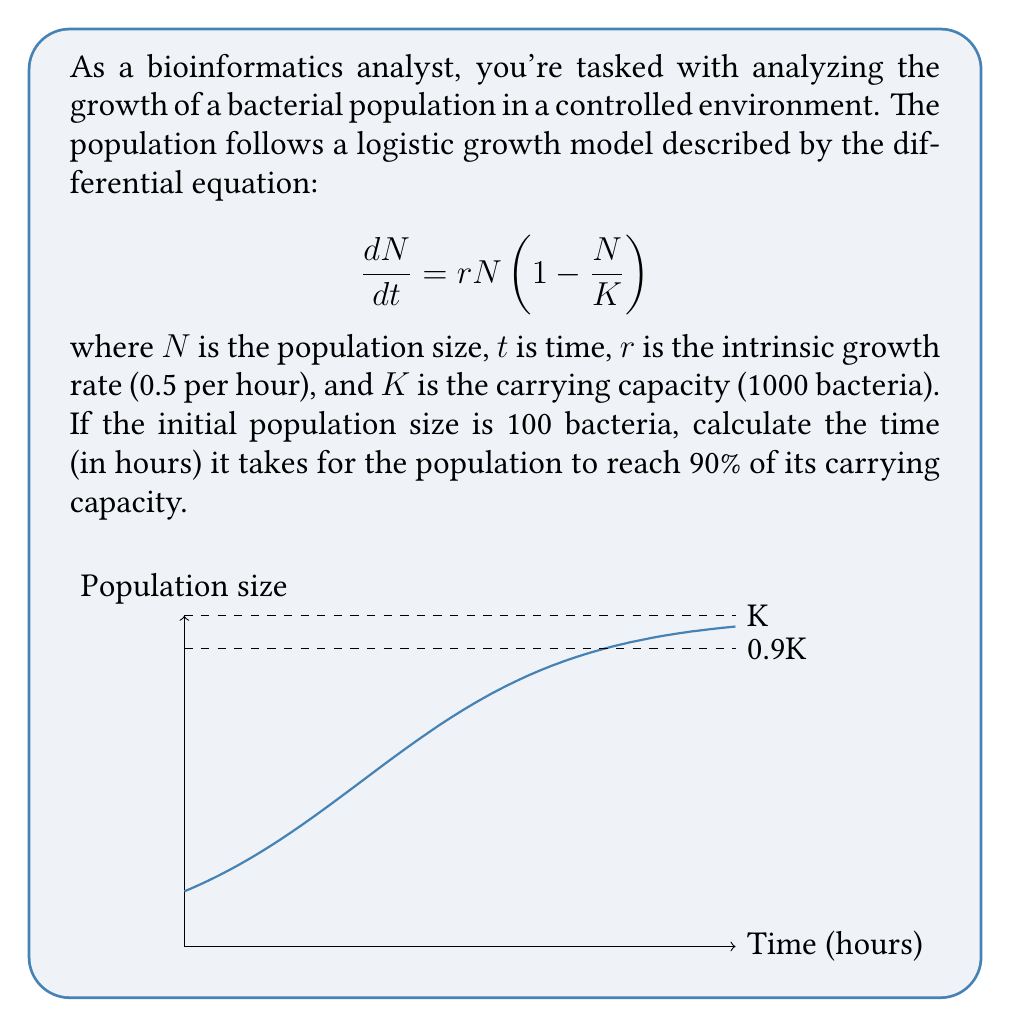Teach me how to tackle this problem. To solve this problem, we'll follow these steps:

1) The logistic growth model has the solution:

   $$N(t) = \frac{K}{1 + (\frac{K}{N_0} - 1)e^{-rt}}$$

   where $N_0$ is the initial population size.

2) We want to find $t$ when $N(t) = 0.9K = 900$. Let's substitute the known values:

   $$900 = \frac{1000}{1 + (\frac{1000}{100} - 1)e^{-0.5t}}$$

3) Simplify:

   $$900 = \frac{1000}{1 + 9e^{-0.5t}}$$

4) Multiply both sides by $(1 + 9e^{-0.5t})$:

   $$900(1 + 9e^{-0.5t}) = 1000$$

5) Expand:

   $$900 + 8100e^{-0.5t} = 1000$$

6) Subtract 900 from both sides:

   $$8100e^{-0.5t} = 100$$

7) Divide both sides by 8100:

   $$e^{-0.5t} = \frac{1}{81}$$

8) Take the natural log of both sides:

   $$-0.5t = \ln(\frac{1}{81}) = -\ln(81)$$

9) Divide both sides by -0.5:

   $$t = \frac{\ln(81)}{0.5} = 2\ln(81) \approx 8.79$$

Therefore, it takes approximately 8.79 hours for the population to reach 90% of its carrying capacity.
Answer: $2\ln(81) \approx 8.79$ hours 